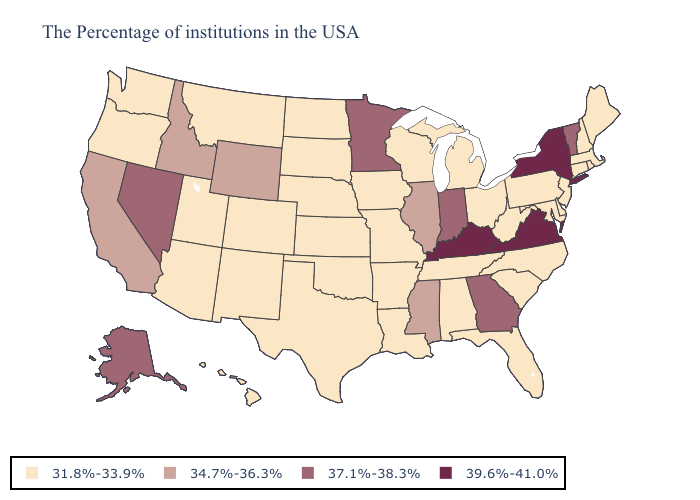What is the value of West Virginia?
Short answer required. 31.8%-33.9%. Does New York have the highest value in the USA?
Answer briefly. Yes. Does New York have the highest value in the Northeast?
Be succinct. Yes. Among the states that border North Dakota , which have the lowest value?
Concise answer only. South Dakota, Montana. Which states have the lowest value in the West?
Short answer required. Colorado, New Mexico, Utah, Montana, Arizona, Washington, Oregon, Hawaii. What is the value of Pennsylvania?
Be succinct. 31.8%-33.9%. Name the states that have a value in the range 34.7%-36.3%?
Be succinct. Illinois, Mississippi, Wyoming, Idaho, California. Does Illinois have the highest value in the USA?
Quick response, please. No. Name the states that have a value in the range 31.8%-33.9%?
Short answer required. Maine, Massachusetts, Rhode Island, New Hampshire, Connecticut, New Jersey, Delaware, Maryland, Pennsylvania, North Carolina, South Carolina, West Virginia, Ohio, Florida, Michigan, Alabama, Tennessee, Wisconsin, Louisiana, Missouri, Arkansas, Iowa, Kansas, Nebraska, Oklahoma, Texas, South Dakota, North Dakota, Colorado, New Mexico, Utah, Montana, Arizona, Washington, Oregon, Hawaii. What is the value of Kentucky?
Concise answer only. 39.6%-41.0%. What is the value of Illinois?
Concise answer only. 34.7%-36.3%. Does the map have missing data?
Short answer required. No. Which states have the lowest value in the USA?
Concise answer only. Maine, Massachusetts, Rhode Island, New Hampshire, Connecticut, New Jersey, Delaware, Maryland, Pennsylvania, North Carolina, South Carolina, West Virginia, Ohio, Florida, Michigan, Alabama, Tennessee, Wisconsin, Louisiana, Missouri, Arkansas, Iowa, Kansas, Nebraska, Oklahoma, Texas, South Dakota, North Dakota, Colorado, New Mexico, Utah, Montana, Arizona, Washington, Oregon, Hawaii. Name the states that have a value in the range 39.6%-41.0%?
Quick response, please. New York, Virginia, Kentucky. Does New York have the highest value in the USA?
Answer briefly. Yes. 